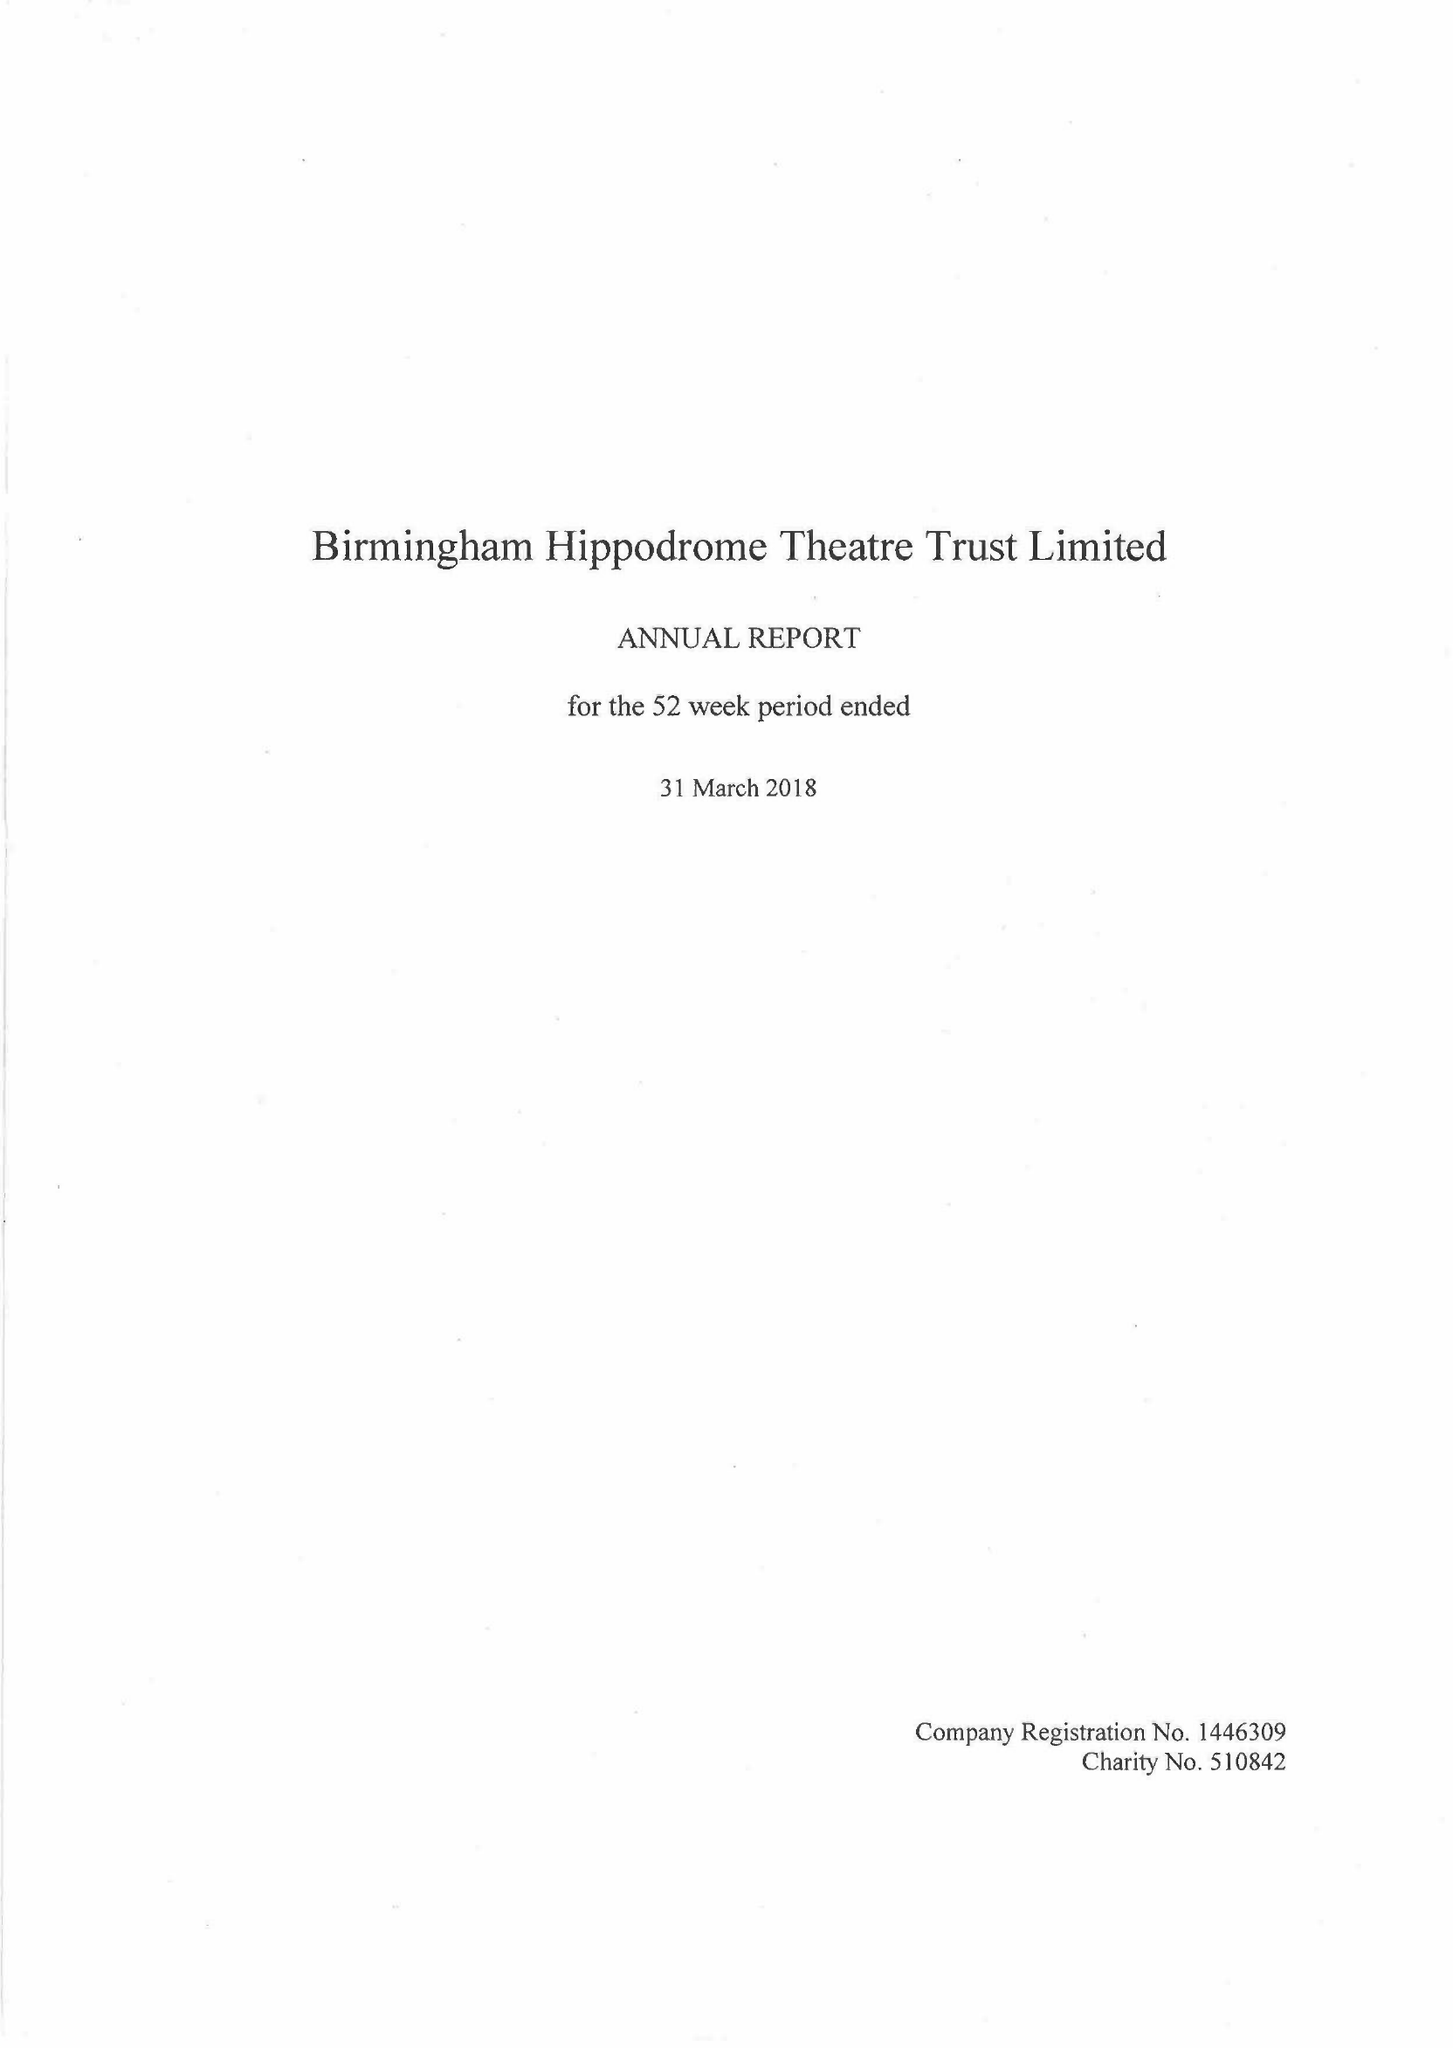What is the value for the spending_annually_in_british_pounds?
Answer the question using a single word or phrase. 26799000.00 